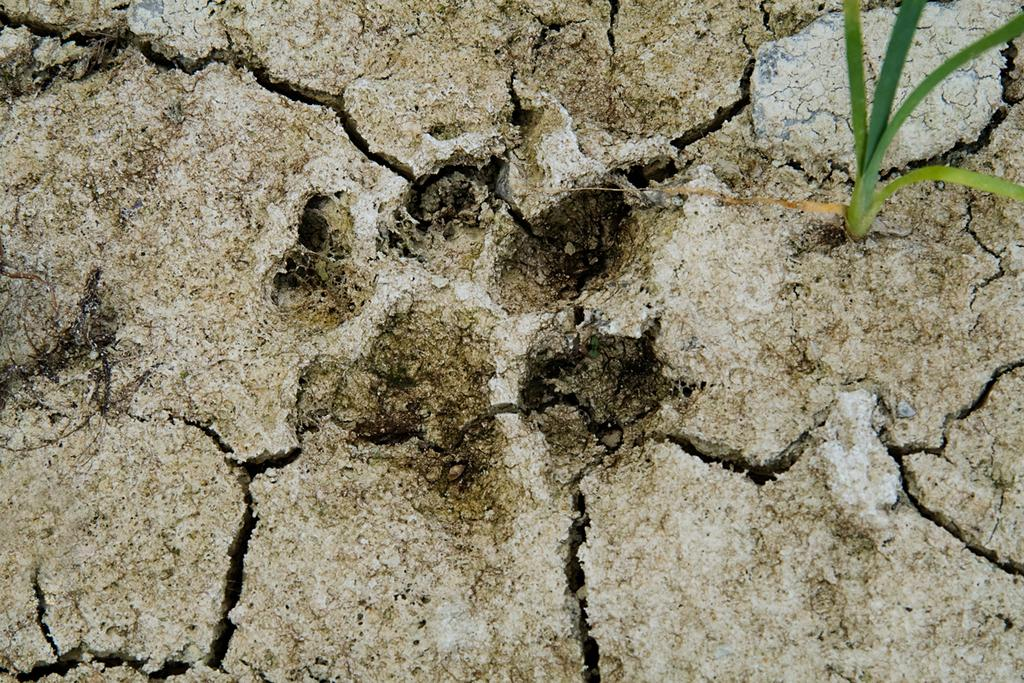What type of surface can be seen in the image? There is ground with cracks in the image. What type of vegetation is present in the image? There is grass visible in the image. What color is the queen's dress in the image? There is no queen present in the image, so it is not possible to determine the color of her dress. 